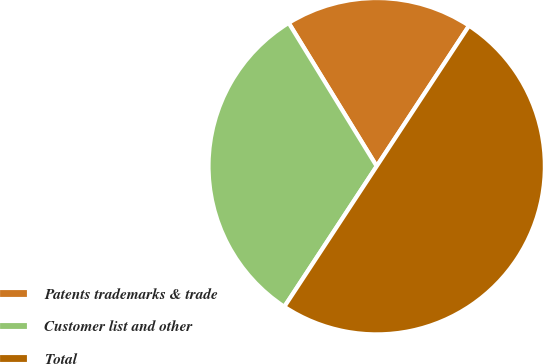Convert chart to OTSL. <chart><loc_0><loc_0><loc_500><loc_500><pie_chart><fcel>Patents trademarks & trade<fcel>Customer list and other<fcel>Total<nl><fcel>18.02%<fcel>31.98%<fcel>50.0%<nl></chart> 